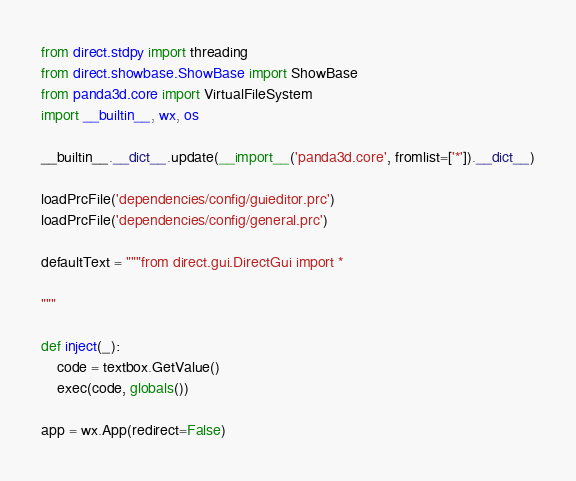Convert code to text. <code><loc_0><loc_0><loc_500><loc_500><_Python_>from direct.stdpy import threading
from direct.showbase.ShowBase import ShowBase
from panda3d.core import VirtualFileSystem
import __builtin__, wx, os

__builtin__.__dict__.update(__import__('panda3d.core', fromlist=['*']).__dict__)

loadPrcFile('dependencies/config/guieditor.prc')
loadPrcFile('dependencies/config/general.prc')

defaultText = """from direct.gui.DirectGui import *

"""

def inject(_):
    code = textbox.GetValue()
    exec(code, globals())

app = wx.App(redirect=False)</code> 